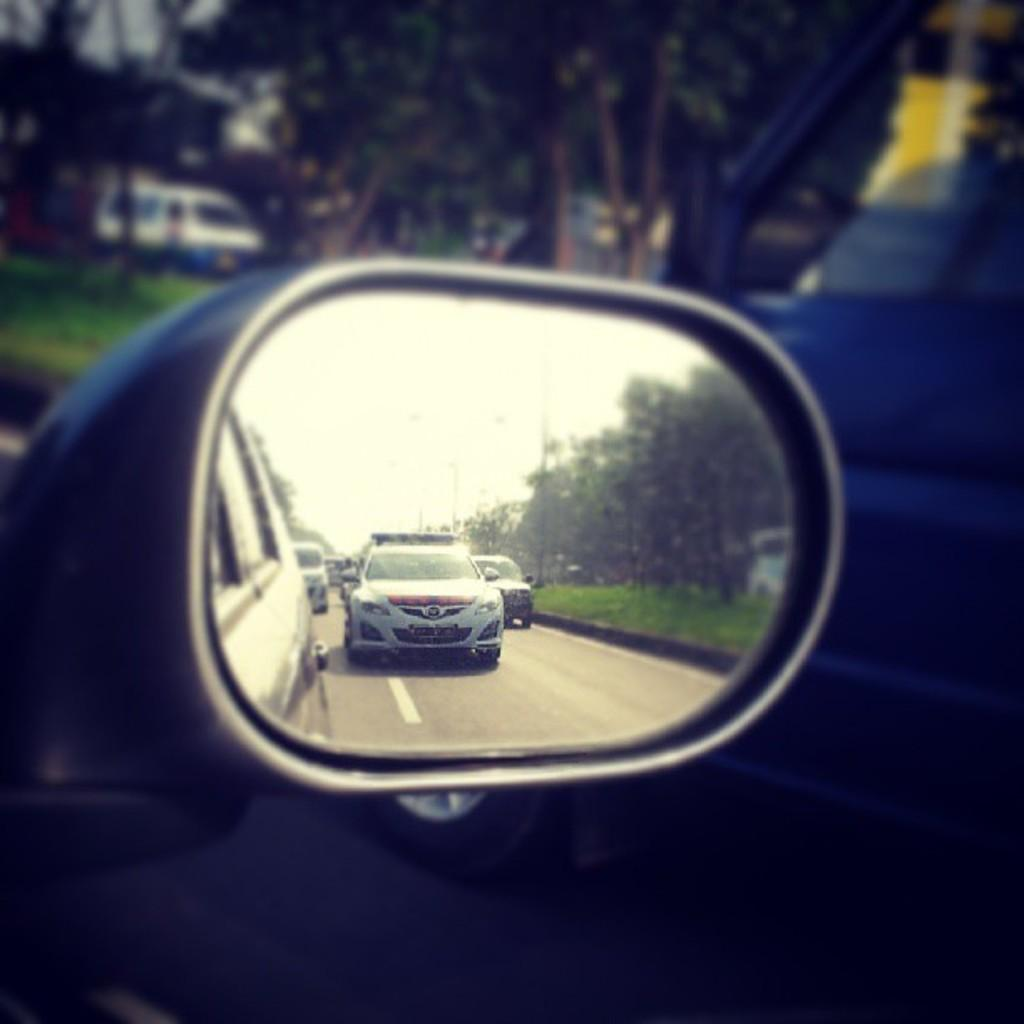What part of a car is shown in the image? There is a side window of a car in the image. What is attached to the side window of the car? There is a side mirror in the image. What can be seen in the side mirror? Cars are parked on the road as seen in the side mirror. What type of natural scenery is visible in the background of the image? There are trees in the background of the image. How is the background of the image depicted? The background is blurred. What type of leather material can be seen on the team's uniforms in the image? There is no team or uniforms present in the image; it features a side window of a car, a side mirror, parked cars, trees, and a blurred background. 